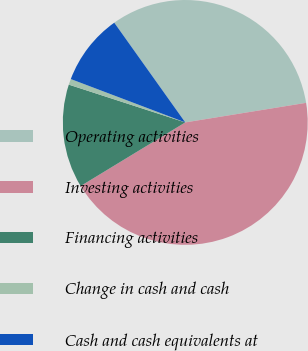Convert chart. <chart><loc_0><loc_0><loc_500><loc_500><pie_chart><fcel>Operating activities<fcel>Investing activities<fcel>Financing activities<fcel>Change in cash and cash<fcel>Cash and cash equivalents at<nl><fcel>32.29%<fcel>43.86%<fcel>13.69%<fcel>0.77%<fcel>9.39%<nl></chart> 